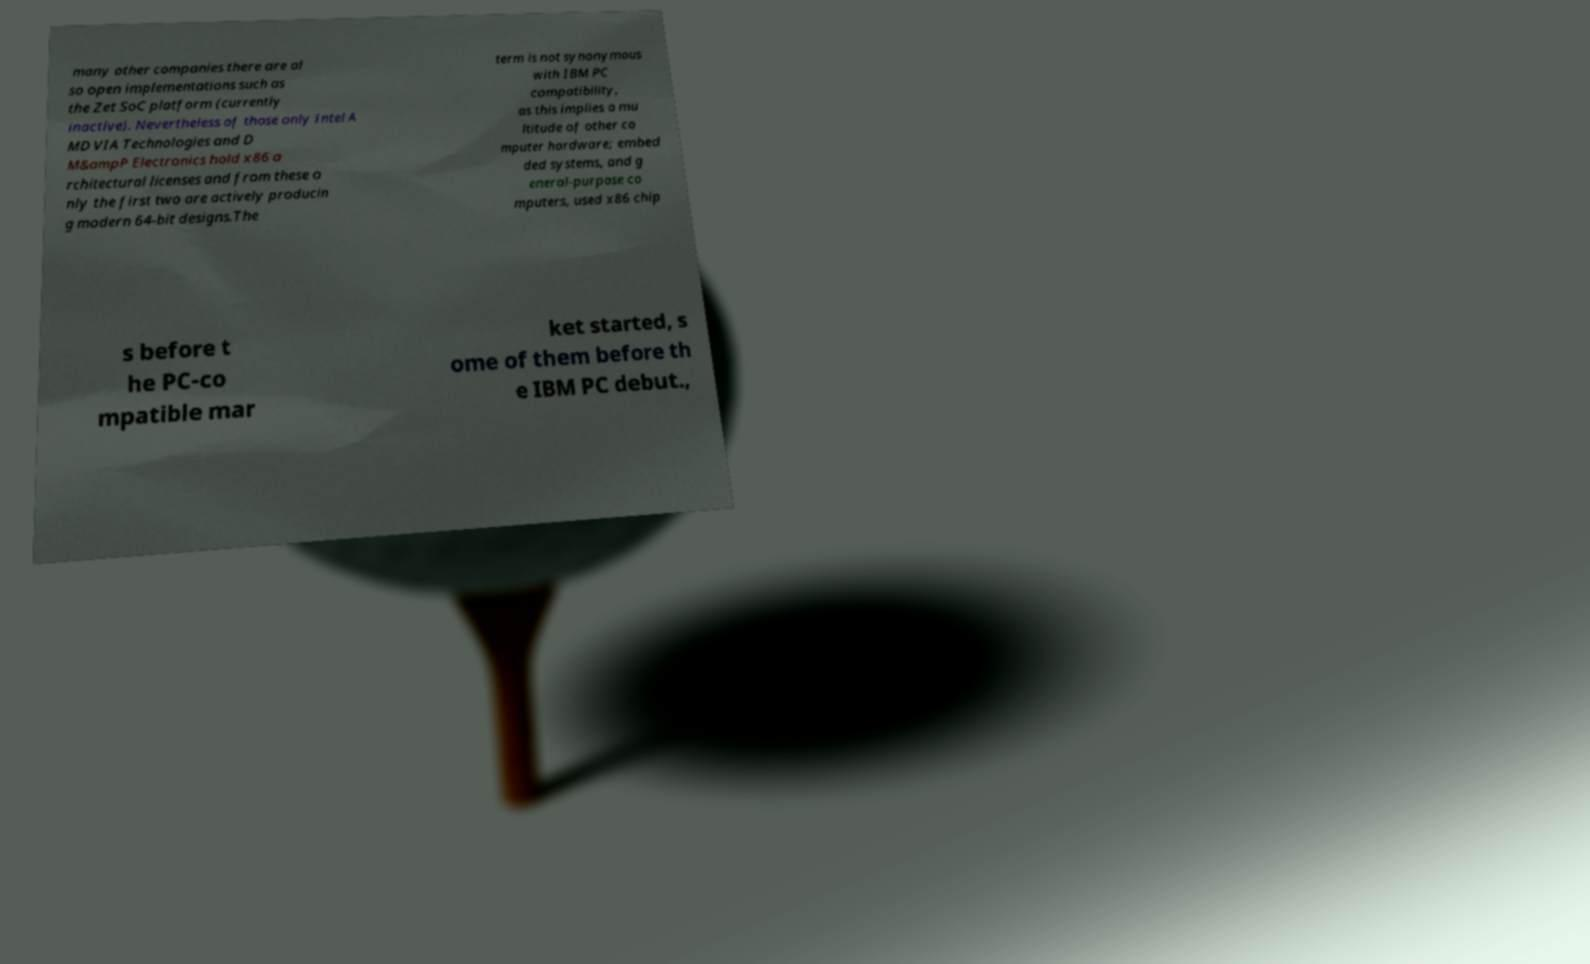There's text embedded in this image that I need extracted. Can you transcribe it verbatim? many other companies there are al so open implementations such as the Zet SoC platform (currently inactive). Nevertheless of those only Intel A MD VIA Technologies and D M&ampP Electronics hold x86 a rchitectural licenses and from these o nly the first two are actively producin g modern 64-bit designs.The term is not synonymous with IBM PC compatibility, as this implies a mu ltitude of other co mputer hardware; embed ded systems, and g eneral-purpose co mputers, used x86 chip s before t he PC-co mpatible mar ket started, s ome of them before th e IBM PC debut., 